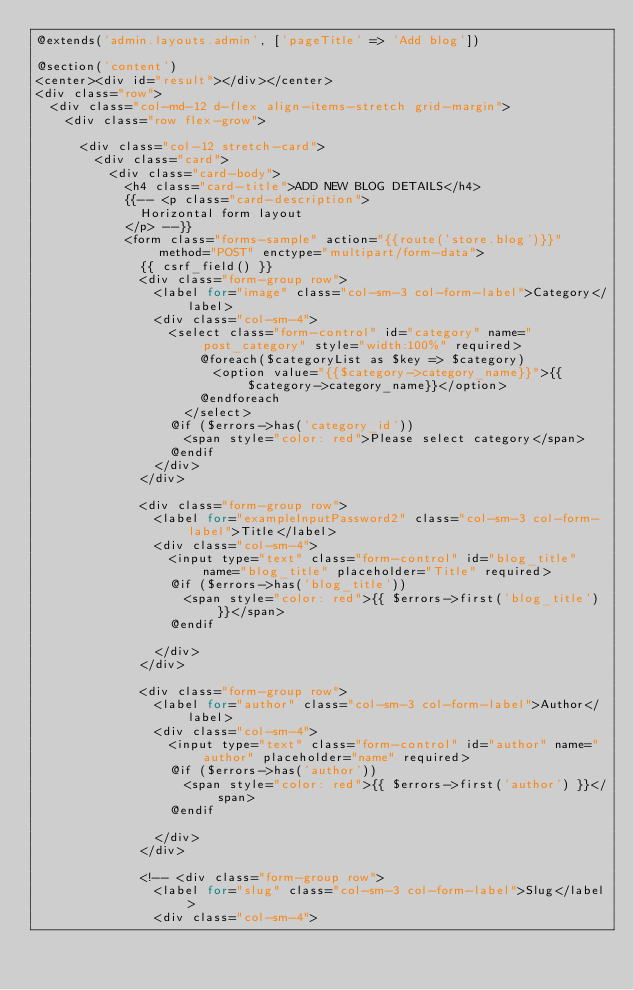Convert code to text. <code><loc_0><loc_0><loc_500><loc_500><_PHP_>@extends('admin.layouts.admin', ['pageTitle' => 'Add blog'])

@section('content')
<center><div id="result"></div></center>
<div class="row">
  <div class="col-md-12 d-flex align-items-stretch grid-margin">
    <div class="row flex-grow">
      
      <div class="col-12 stretch-card">
        <div class="card">
          <div class="card-body">
            <h4 class="card-title">ADD NEW BLOG DETAILS</h4>
            {{-- <p class="card-description">
              Horizontal form layout
            </p> --}}
            <form class="forms-sample" action="{{route('store.blog')}}" method="POST" enctype="multipart/form-data">
              {{ csrf_field() }}
              <div class="form-group row">
                <label for="image" class="col-sm-3 col-form-label">Category</label>
                <div class="col-sm-4">
                  <select class="form-control" id="category" name="post_category" style="width:100%" required>
                      @foreach($categoryList as $key => $category)
                        <option value="{{$category->category_name}}">{{$category->category_name}}</option>
                      @endforeach
                    </select>
                  @if ($errors->has('category_id'))
                    <span style="color: red">Please select category</span>
                  @endif
                </div>
              </div>

              <div class="form-group row">
                <label for="exampleInputPassword2" class="col-sm-3 col-form-label">Title</label>
                <div class="col-sm-4">
                  <input type="text" class="form-control" id="blog_title" name="blog_title" placeholder="Title" required>
                  @if ($errors->has('blog_title'))
                    <span style="color: red">{{ $errors->first('blog_title') }}</span>
                  @endif
                  
                </div>
              </div>

              <div class="form-group row">
                <label for="author" class="col-sm-3 col-form-label">Author</label>
                <div class="col-sm-4">
                  <input type="text" class="form-control" id="author" name="author" placeholder="name" required>
                  @if ($errors->has('author'))
                    <span style="color: red">{{ $errors->first('author') }}</span>
                  @endif
                  
                </div>
              </div>

              <!-- <div class="form-group row">
                <label for="slug" class="col-sm-3 col-form-label">Slug</label>
                <div class="col-sm-4"></code> 